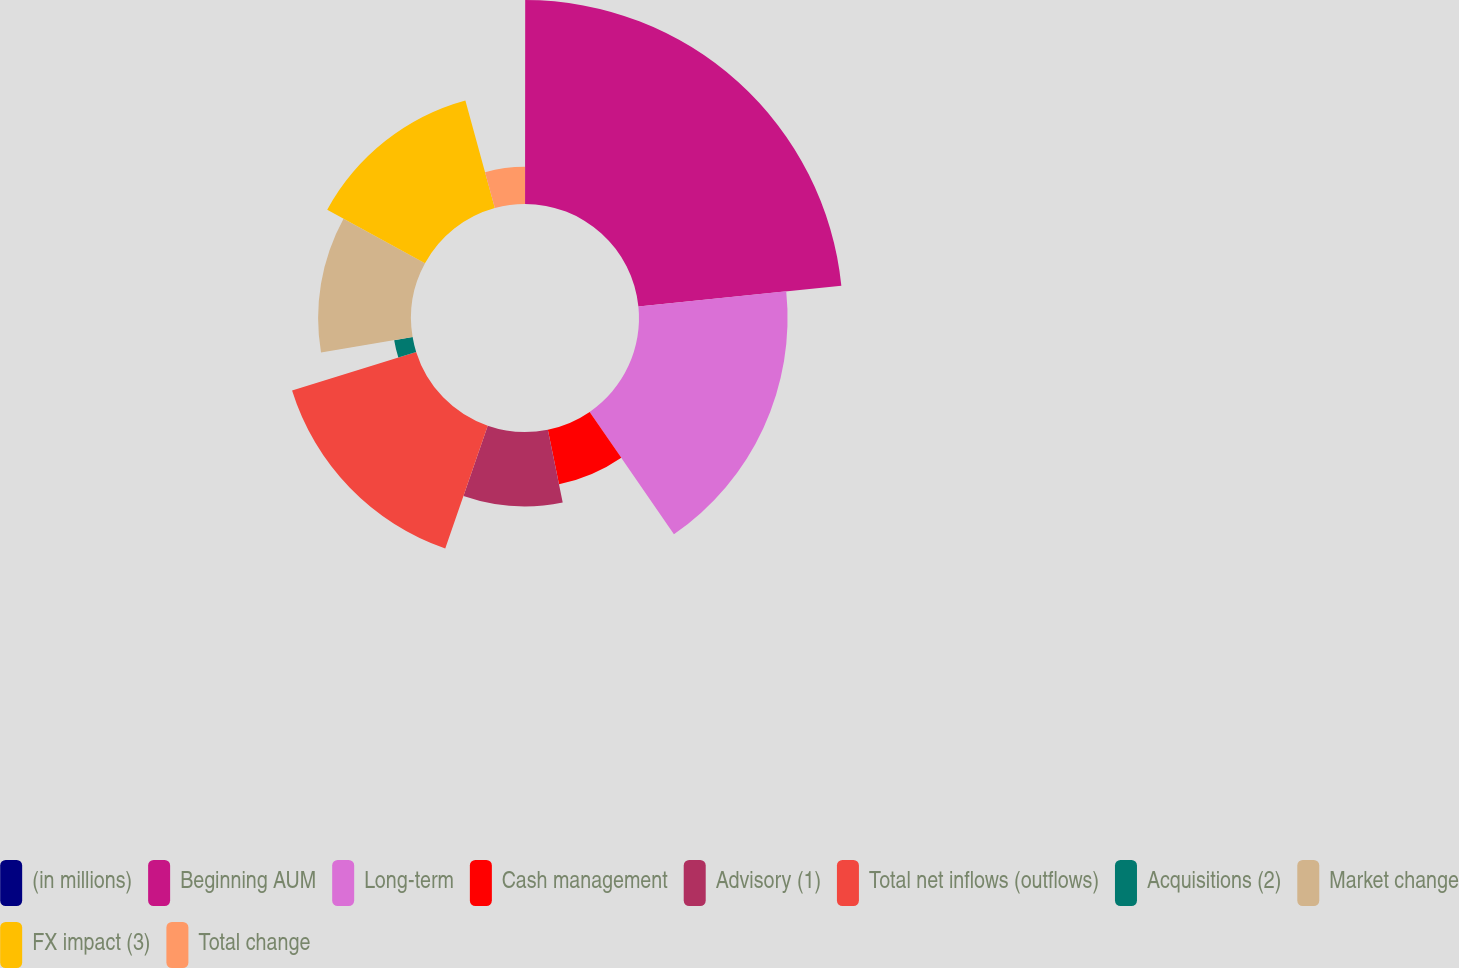Convert chart. <chart><loc_0><loc_0><loc_500><loc_500><pie_chart><fcel>(in millions)<fcel>Beginning AUM<fcel>Long-term<fcel>Cash management<fcel>Advisory (1)<fcel>Total net inflows (outflows)<fcel>Acquisitions (2)<fcel>Market change<fcel>FX impact (3)<fcel>Total change<nl><fcel>0.01%<fcel>23.37%<fcel>17.02%<fcel>6.39%<fcel>8.51%<fcel>14.89%<fcel>2.14%<fcel>10.64%<fcel>12.77%<fcel>4.26%<nl></chart> 